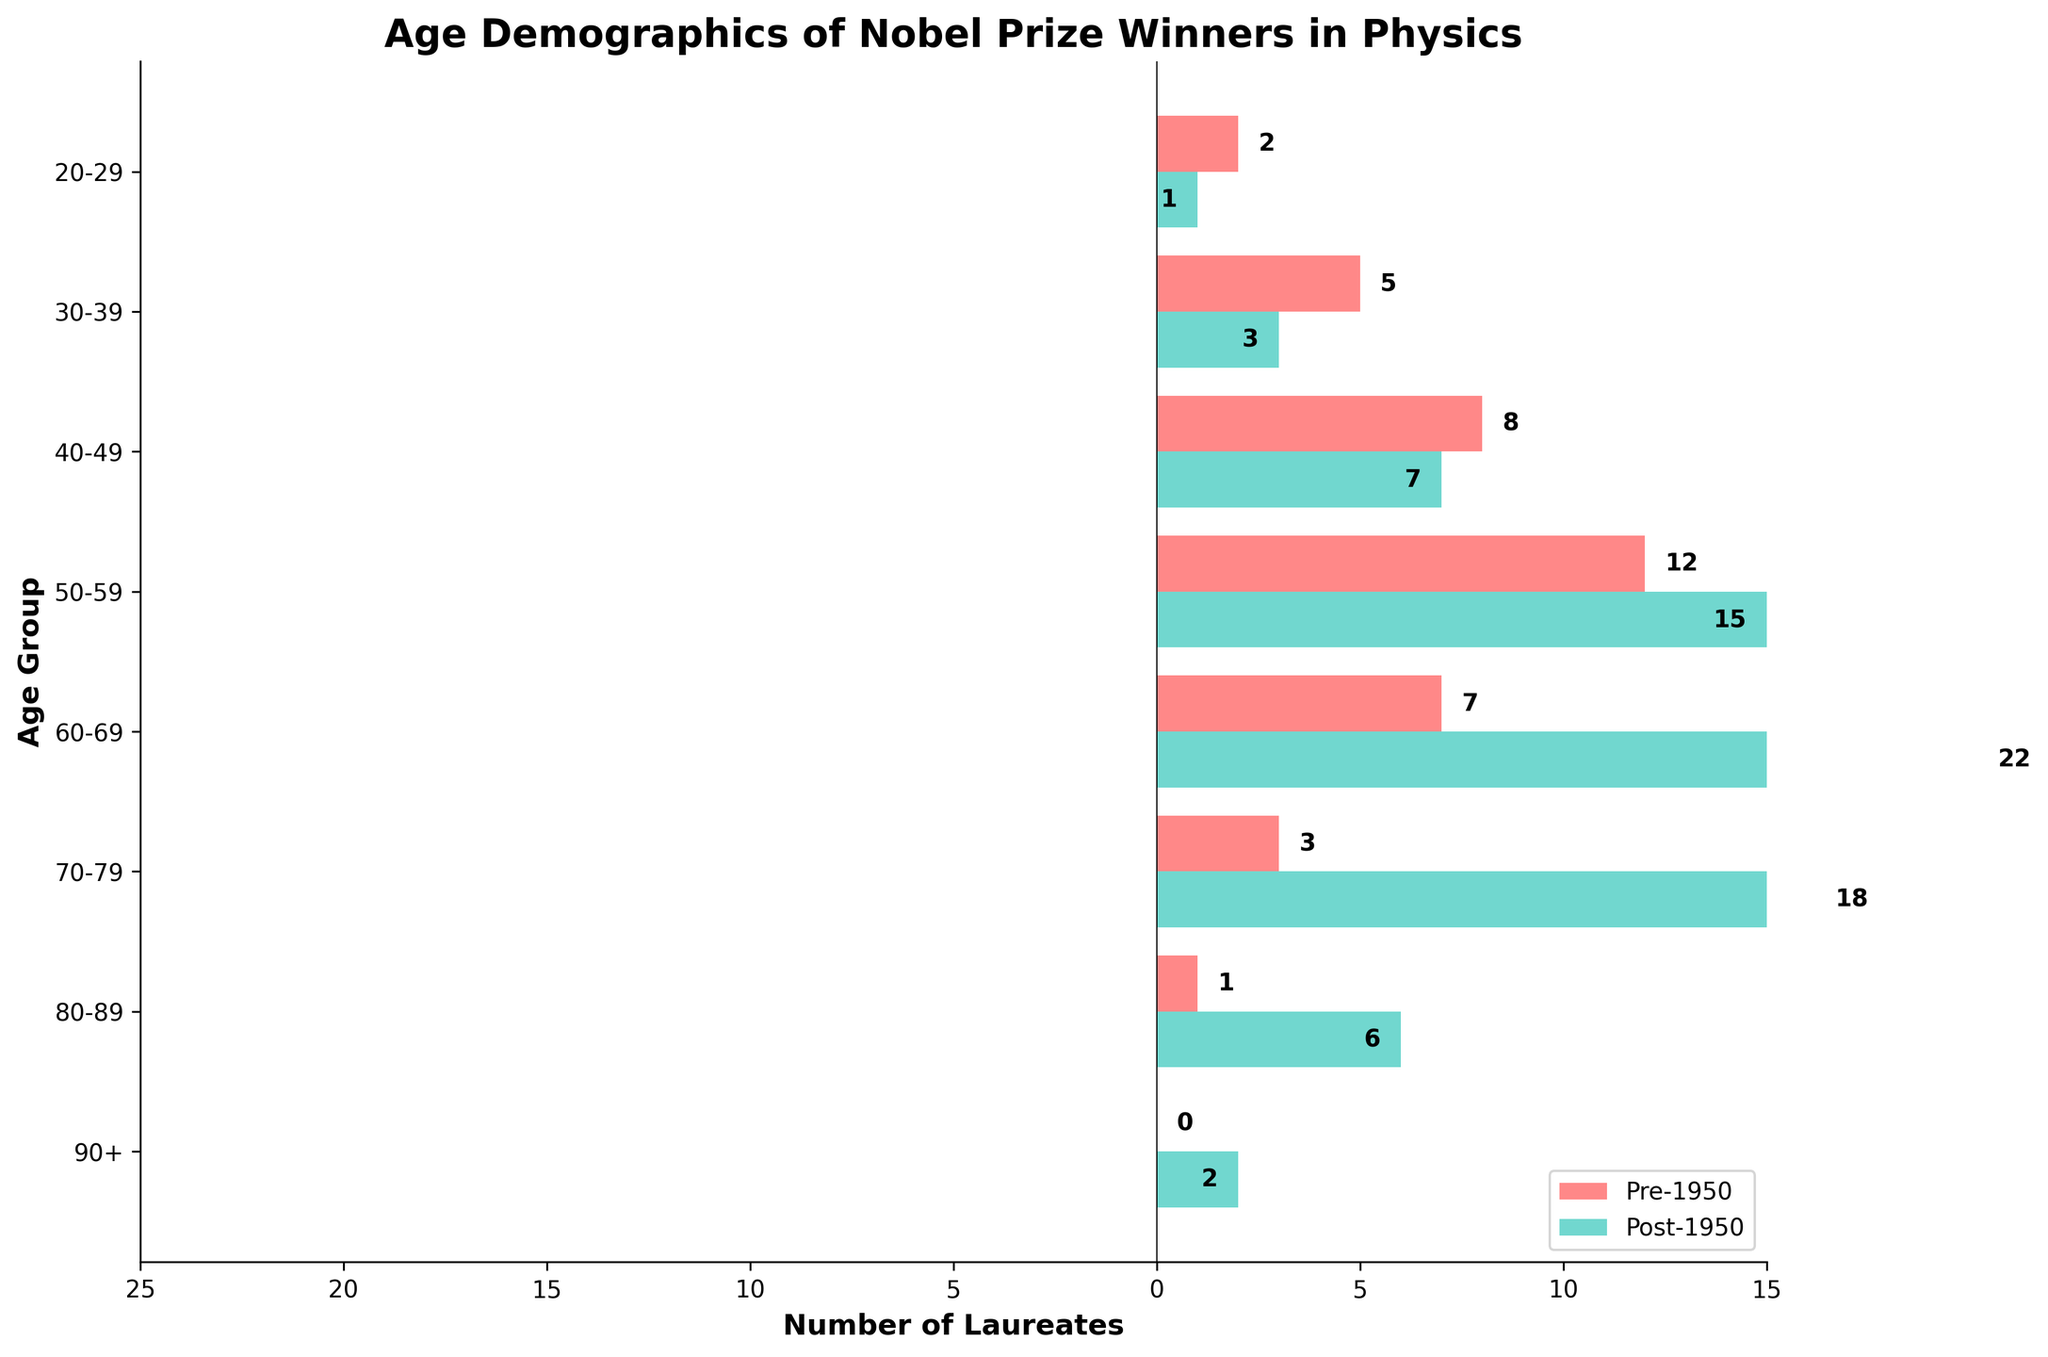What's the title of the plot? The title of the plot is found at the center-top of the figure, written in bold. One can see that the title reads "Age Demographics of Nobel Prize Winners in Physics".
Answer: Age Demographics of Nobel Prize Winners in Physics What are the colors representing Pre-1950 and Post-1950 laureates in the figure? The colors are visible in the legend located at the lower right of the figure. Pre-1950 laureates are represented in red and Post-1950 laureates are represented in teal.
Answer: Red for Pre-1950 and Teal for Post-1950 How many Nobel Prize winners in Physics were aged 50-59 in the Pre-1950 category? By looking at the bar labeled "50-59" on the left side of the plot, you can see that the 'Pre-1950' bar extends to 12.
Answer: 12 What is the difference in the number of Nobel Prize winners aged 60-69 between Pre-1950 and Post-1950? One needs to compare the lengths of the bars corresponding to the "60-69" age group on both sides of the pyramid. Pre-1950 has 7 laureates, while Post-1950 has 22 laureates (the value is negative for bar length but positive when counted). Therefore, the difference is 22 - 7.
Answer: 15 Which age group had the highest number of Pre-1950 laureates? Observing the lengths of the bars on the left side of the plot helps identify that the "50-59" age group, with a bar extending to 12, had the highest number.
Answer: 50-59 Have there been any Nobel Prize winners in Physics aged 90+ post-1950? By looking at the bar labeled "90+" on the right side of the plot, it is clear that the 'Post-1950' bar extends to 2.
Answer: Yes What is the sum of laureates aged 40-49 and 50-59 in the Post-1950 category? From the "40-49" and "50-59" age group bars on the right side, we see there were 7 laureates aged 40-49 and 15 laureates aged 50-59. Summing them gives 7 + 15.
Answer: 22 Which age group shows a more significant difference in the number of laureates between Pre-1950 and Post-1950, the "60-69" group or the "70-79" group? For "60-69", the difference is 22 (Post-1950) - 7 (Pre-1950) = 15. For "70-79", the difference is 18 (Post-1950) - 3 (Pre-1950) = 15. Hence, both age groups show the same significant difference.
Answer: Both groups have the same difference, 15 How many laureates in total were there in the age groups 30-39 and 80-89 for Pre-1950 winners? The number of laureates aged 30-39 is 5 and those aged 80-89 is 1. Adding these gives 5 + 1.
Answer: 6 